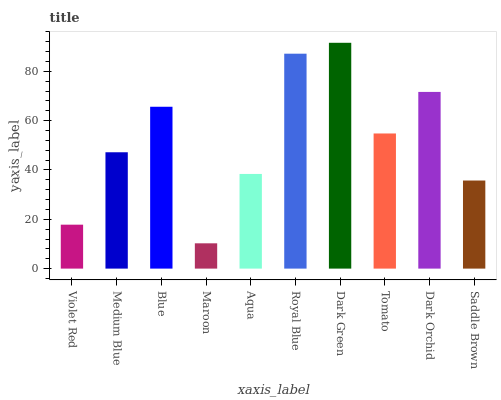Is Medium Blue the minimum?
Answer yes or no. No. Is Medium Blue the maximum?
Answer yes or no. No. Is Medium Blue greater than Violet Red?
Answer yes or no. Yes. Is Violet Red less than Medium Blue?
Answer yes or no. Yes. Is Violet Red greater than Medium Blue?
Answer yes or no. No. Is Medium Blue less than Violet Red?
Answer yes or no. No. Is Tomato the high median?
Answer yes or no. Yes. Is Medium Blue the low median?
Answer yes or no. Yes. Is Maroon the high median?
Answer yes or no. No. Is Blue the low median?
Answer yes or no. No. 